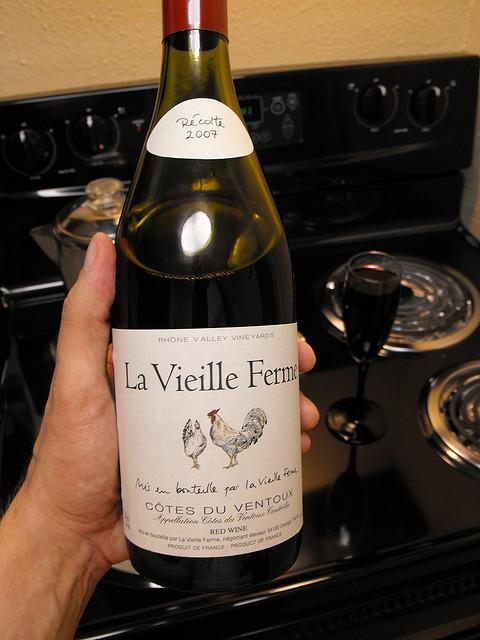What gift would this person enjoy assuming they like what they are holding? Please explain your reasoning. wine rack. They are holding a bottle of mild alcohol. 